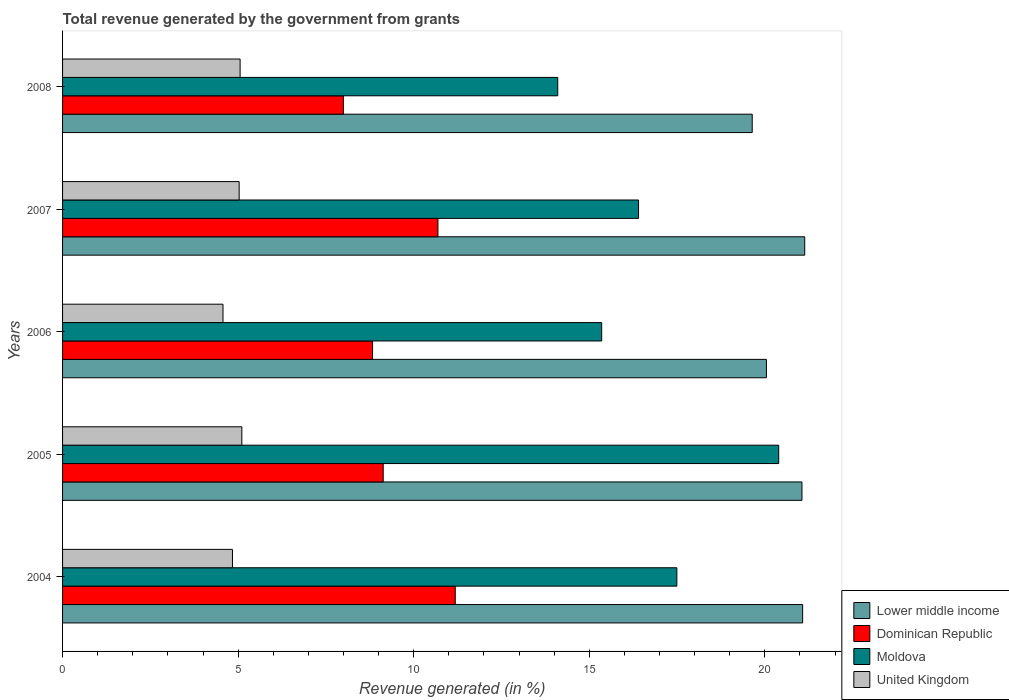How many different coloured bars are there?
Provide a short and direct response. 4. How many groups of bars are there?
Provide a short and direct response. 5. Are the number of bars per tick equal to the number of legend labels?
Make the answer very short. Yes. Are the number of bars on each tick of the Y-axis equal?
Offer a very short reply. Yes. What is the label of the 3rd group of bars from the top?
Your answer should be very brief. 2006. What is the total revenue generated in Lower middle income in 2007?
Keep it short and to the point. 21.14. Across all years, what is the maximum total revenue generated in Lower middle income?
Make the answer very short. 21.14. Across all years, what is the minimum total revenue generated in Dominican Republic?
Your answer should be compact. 8. In which year was the total revenue generated in Lower middle income maximum?
Your answer should be compact. 2007. What is the total total revenue generated in Lower middle income in the graph?
Provide a succinct answer. 102.96. What is the difference between the total revenue generated in United Kingdom in 2007 and that in 2008?
Ensure brevity in your answer.  -0.03. What is the difference between the total revenue generated in Dominican Republic in 2004 and the total revenue generated in United Kingdom in 2008?
Make the answer very short. 6.13. What is the average total revenue generated in United Kingdom per year?
Provide a short and direct response. 4.92. In the year 2008, what is the difference between the total revenue generated in Dominican Republic and total revenue generated in Moldova?
Give a very brief answer. -6.11. What is the ratio of the total revenue generated in Lower middle income in 2007 to that in 2008?
Ensure brevity in your answer.  1.08. Is the difference between the total revenue generated in Dominican Republic in 2004 and 2007 greater than the difference between the total revenue generated in Moldova in 2004 and 2007?
Provide a short and direct response. No. What is the difference between the highest and the second highest total revenue generated in Moldova?
Give a very brief answer. 2.9. What is the difference between the highest and the lowest total revenue generated in United Kingdom?
Your answer should be compact. 0.54. In how many years, is the total revenue generated in United Kingdom greater than the average total revenue generated in United Kingdom taken over all years?
Keep it short and to the point. 3. Is the sum of the total revenue generated in Dominican Republic in 2004 and 2005 greater than the maximum total revenue generated in Moldova across all years?
Give a very brief answer. No. Is it the case that in every year, the sum of the total revenue generated in Lower middle income and total revenue generated in Moldova is greater than the sum of total revenue generated in Dominican Republic and total revenue generated in United Kingdom?
Your answer should be compact. No. What does the 3rd bar from the top in 2007 represents?
Keep it short and to the point. Dominican Republic. What does the 4th bar from the bottom in 2004 represents?
Provide a succinct answer. United Kingdom. Is it the case that in every year, the sum of the total revenue generated in Lower middle income and total revenue generated in United Kingdom is greater than the total revenue generated in Moldova?
Your answer should be compact. Yes. Are all the bars in the graph horizontal?
Your answer should be compact. Yes. How many years are there in the graph?
Your response must be concise. 5. What is the difference between two consecutive major ticks on the X-axis?
Provide a short and direct response. 5. Does the graph contain grids?
Offer a terse response. No. What is the title of the graph?
Keep it short and to the point. Total revenue generated by the government from grants. Does "Nicaragua" appear as one of the legend labels in the graph?
Offer a very short reply. No. What is the label or title of the X-axis?
Keep it short and to the point. Revenue generated (in %). What is the Revenue generated (in %) of Lower middle income in 2004?
Keep it short and to the point. 21.08. What is the Revenue generated (in %) of Dominican Republic in 2004?
Your answer should be compact. 11.18. What is the Revenue generated (in %) in Moldova in 2004?
Ensure brevity in your answer.  17.5. What is the Revenue generated (in %) in United Kingdom in 2004?
Keep it short and to the point. 4.84. What is the Revenue generated (in %) of Lower middle income in 2005?
Offer a very short reply. 21.06. What is the Revenue generated (in %) in Dominican Republic in 2005?
Your answer should be compact. 9.13. What is the Revenue generated (in %) of Moldova in 2005?
Your answer should be compact. 20.4. What is the Revenue generated (in %) of United Kingdom in 2005?
Give a very brief answer. 5.11. What is the Revenue generated (in %) in Lower middle income in 2006?
Keep it short and to the point. 20.05. What is the Revenue generated (in %) in Dominican Republic in 2006?
Give a very brief answer. 8.83. What is the Revenue generated (in %) of Moldova in 2006?
Ensure brevity in your answer.  15.35. What is the Revenue generated (in %) in United Kingdom in 2006?
Ensure brevity in your answer.  4.57. What is the Revenue generated (in %) in Lower middle income in 2007?
Your answer should be compact. 21.14. What is the Revenue generated (in %) in Dominican Republic in 2007?
Offer a terse response. 10.69. What is the Revenue generated (in %) in Moldova in 2007?
Keep it short and to the point. 16.4. What is the Revenue generated (in %) in United Kingdom in 2007?
Keep it short and to the point. 5.03. What is the Revenue generated (in %) in Lower middle income in 2008?
Make the answer very short. 19.64. What is the Revenue generated (in %) in Dominican Republic in 2008?
Make the answer very short. 8. What is the Revenue generated (in %) of Moldova in 2008?
Keep it short and to the point. 14.1. What is the Revenue generated (in %) of United Kingdom in 2008?
Your answer should be compact. 5.06. Across all years, what is the maximum Revenue generated (in %) in Lower middle income?
Offer a terse response. 21.14. Across all years, what is the maximum Revenue generated (in %) of Dominican Republic?
Make the answer very short. 11.18. Across all years, what is the maximum Revenue generated (in %) of Moldova?
Offer a very short reply. 20.4. Across all years, what is the maximum Revenue generated (in %) in United Kingdom?
Provide a short and direct response. 5.11. Across all years, what is the minimum Revenue generated (in %) of Lower middle income?
Give a very brief answer. 19.64. Across all years, what is the minimum Revenue generated (in %) in Dominican Republic?
Give a very brief answer. 8. Across all years, what is the minimum Revenue generated (in %) in Moldova?
Make the answer very short. 14.1. Across all years, what is the minimum Revenue generated (in %) in United Kingdom?
Offer a very short reply. 4.57. What is the total Revenue generated (in %) of Lower middle income in the graph?
Ensure brevity in your answer.  102.96. What is the total Revenue generated (in %) of Dominican Republic in the graph?
Your response must be concise. 47.83. What is the total Revenue generated (in %) in Moldova in the graph?
Provide a short and direct response. 83.75. What is the total Revenue generated (in %) of United Kingdom in the graph?
Your response must be concise. 24.6. What is the difference between the Revenue generated (in %) in Lower middle income in 2004 and that in 2005?
Provide a short and direct response. 0.02. What is the difference between the Revenue generated (in %) in Dominican Republic in 2004 and that in 2005?
Provide a succinct answer. 2.05. What is the difference between the Revenue generated (in %) in Moldova in 2004 and that in 2005?
Provide a succinct answer. -2.9. What is the difference between the Revenue generated (in %) in United Kingdom in 2004 and that in 2005?
Your response must be concise. -0.27. What is the difference between the Revenue generated (in %) of Lower middle income in 2004 and that in 2006?
Provide a short and direct response. 1.03. What is the difference between the Revenue generated (in %) of Dominican Republic in 2004 and that in 2006?
Ensure brevity in your answer.  2.35. What is the difference between the Revenue generated (in %) in Moldova in 2004 and that in 2006?
Your answer should be very brief. 2.14. What is the difference between the Revenue generated (in %) of United Kingdom in 2004 and that in 2006?
Provide a short and direct response. 0.27. What is the difference between the Revenue generated (in %) in Lower middle income in 2004 and that in 2007?
Give a very brief answer. -0.06. What is the difference between the Revenue generated (in %) of Dominican Republic in 2004 and that in 2007?
Your answer should be compact. 0.49. What is the difference between the Revenue generated (in %) in Moldova in 2004 and that in 2007?
Keep it short and to the point. 1.09. What is the difference between the Revenue generated (in %) in United Kingdom in 2004 and that in 2007?
Give a very brief answer. -0.19. What is the difference between the Revenue generated (in %) of Lower middle income in 2004 and that in 2008?
Your response must be concise. 1.44. What is the difference between the Revenue generated (in %) in Dominican Republic in 2004 and that in 2008?
Offer a very short reply. 3.19. What is the difference between the Revenue generated (in %) of Moldova in 2004 and that in 2008?
Ensure brevity in your answer.  3.39. What is the difference between the Revenue generated (in %) in United Kingdom in 2004 and that in 2008?
Offer a terse response. -0.22. What is the difference between the Revenue generated (in %) in Lower middle income in 2005 and that in 2006?
Keep it short and to the point. 1.01. What is the difference between the Revenue generated (in %) of Dominican Republic in 2005 and that in 2006?
Provide a succinct answer. 0.3. What is the difference between the Revenue generated (in %) in Moldova in 2005 and that in 2006?
Offer a terse response. 5.04. What is the difference between the Revenue generated (in %) of United Kingdom in 2005 and that in 2006?
Provide a short and direct response. 0.54. What is the difference between the Revenue generated (in %) in Lower middle income in 2005 and that in 2007?
Your answer should be very brief. -0.08. What is the difference between the Revenue generated (in %) in Dominican Republic in 2005 and that in 2007?
Provide a short and direct response. -1.56. What is the difference between the Revenue generated (in %) of Moldova in 2005 and that in 2007?
Offer a terse response. 3.99. What is the difference between the Revenue generated (in %) in United Kingdom in 2005 and that in 2007?
Make the answer very short. 0.08. What is the difference between the Revenue generated (in %) of Lower middle income in 2005 and that in 2008?
Your answer should be very brief. 1.42. What is the difference between the Revenue generated (in %) of Dominican Republic in 2005 and that in 2008?
Your response must be concise. 1.14. What is the difference between the Revenue generated (in %) of Moldova in 2005 and that in 2008?
Make the answer very short. 6.29. What is the difference between the Revenue generated (in %) of United Kingdom in 2005 and that in 2008?
Make the answer very short. 0.05. What is the difference between the Revenue generated (in %) of Lower middle income in 2006 and that in 2007?
Offer a very short reply. -1.09. What is the difference between the Revenue generated (in %) of Dominican Republic in 2006 and that in 2007?
Keep it short and to the point. -1.86. What is the difference between the Revenue generated (in %) of Moldova in 2006 and that in 2007?
Make the answer very short. -1.05. What is the difference between the Revenue generated (in %) of United Kingdom in 2006 and that in 2007?
Keep it short and to the point. -0.46. What is the difference between the Revenue generated (in %) in Lower middle income in 2006 and that in 2008?
Ensure brevity in your answer.  0.4. What is the difference between the Revenue generated (in %) of Dominican Republic in 2006 and that in 2008?
Give a very brief answer. 0.83. What is the difference between the Revenue generated (in %) in Moldova in 2006 and that in 2008?
Provide a succinct answer. 1.25. What is the difference between the Revenue generated (in %) in United Kingdom in 2006 and that in 2008?
Offer a terse response. -0.49. What is the difference between the Revenue generated (in %) of Lower middle income in 2007 and that in 2008?
Provide a succinct answer. 1.5. What is the difference between the Revenue generated (in %) of Dominican Republic in 2007 and that in 2008?
Your response must be concise. 2.69. What is the difference between the Revenue generated (in %) in Moldova in 2007 and that in 2008?
Offer a terse response. 2.3. What is the difference between the Revenue generated (in %) in United Kingdom in 2007 and that in 2008?
Provide a succinct answer. -0.03. What is the difference between the Revenue generated (in %) in Lower middle income in 2004 and the Revenue generated (in %) in Dominican Republic in 2005?
Provide a succinct answer. 11.95. What is the difference between the Revenue generated (in %) in Lower middle income in 2004 and the Revenue generated (in %) in Moldova in 2005?
Give a very brief answer. 0.68. What is the difference between the Revenue generated (in %) in Lower middle income in 2004 and the Revenue generated (in %) in United Kingdom in 2005?
Make the answer very short. 15.97. What is the difference between the Revenue generated (in %) of Dominican Republic in 2004 and the Revenue generated (in %) of Moldova in 2005?
Your response must be concise. -9.21. What is the difference between the Revenue generated (in %) in Dominican Republic in 2004 and the Revenue generated (in %) in United Kingdom in 2005?
Provide a short and direct response. 6.08. What is the difference between the Revenue generated (in %) of Moldova in 2004 and the Revenue generated (in %) of United Kingdom in 2005?
Provide a succinct answer. 12.39. What is the difference between the Revenue generated (in %) in Lower middle income in 2004 and the Revenue generated (in %) in Dominican Republic in 2006?
Your answer should be very brief. 12.25. What is the difference between the Revenue generated (in %) of Lower middle income in 2004 and the Revenue generated (in %) of Moldova in 2006?
Give a very brief answer. 5.72. What is the difference between the Revenue generated (in %) of Lower middle income in 2004 and the Revenue generated (in %) of United Kingdom in 2006?
Give a very brief answer. 16.51. What is the difference between the Revenue generated (in %) of Dominican Republic in 2004 and the Revenue generated (in %) of Moldova in 2006?
Make the answer very short. -4.17. What is the difference between the Revenue generated (in %) of Dominican Republic in 2004 and the Revenue generated (in %) of United Kingdom in 2006?
Offer a very short reply. 6.61. What is the difference between the Revenue generated (in %) of Moldova in 2004 and the Revenue generated (in %) of United Kingdom in 2006?
Your response must be concise. 12.93. What is the difference between the Revenue generated (in %) in Lower middle income in 2004 and the Revenue generated (in %) in Dominican Republic in 2007?
Your answer should be compact. 10.39. What is the difference between the Revenue generated (in %) of Lower middle income in 2004 and the Revenue generated (in %) of Moldova in 2007?
Provide a short and direct response. 4.67. What is the difference between the Revenue generated (in %) in Lower middle income in 2004 and the Revenue generated (in %) in United Kingdom in 2007?
Your answer should be compact. 16.05. What is the difference between the Revenue generated (in %) of Dominican Republic in 2004 and the Revenue generated (in %) of Moldova in 2007?
Provide a succinct answer. -5.22. What is the difference between the Revenue generated (in %) of Dominican Republic in 2004 and the Revenue generated (in %) of United Kingdom in 2007?
Offer a terse response. 6.15. What is the difference between the Revenue generated (in %) of Moldova in 2004 and the Revenue generated (in %) of United Kingdom in 2007?
Your answer should be compact. 12.47. What is the difference between the Revenue generated (in %) of Lower middle income in 2004 and the Revenue generated (in %) of Dominican Republic in 2008?
Offer a terse response. 13.08. What is the difference between the Revenue generated (in %) in Lower middle income in 2004 and the Revenue generated (in %) in Moldova in 2008?
Your answer should be very brief. 6.97. What is the difference between the Revenue generated (in %) of Lower middle income in 2004 and the Revenue generated (in %) of United Kingdom in 2008?
Your answer should be compact. 16.02. What is the difference between the Revenue generated (in %) of Dominican Republic in 2004 and the Revenue generated (in %) of Moldova in 2008?
Your answer should be very brief. -2.92. What is the difference between the Revenue generated (in %) in Dominican Republic in 2004 and the Revenue generated (in %) in United Kingdom in 2008?
Your answer should be very brief. 6.13. What is the difference between the Revenue generated (in %) of Moldova in 2004 and the Revenue generated (in %) of United Kingdom in 2008?
Make the answer very short. 12.44. What is the difference between the Revenue generated (in %) in Lower middle income in 2005 and the Revenue generated (in %) in Dominican Republic in 2006?
Your answer should be compact. 12.23. What is the difference between the Revenue generated (in %) in Lower middle income in 2005 and the Revenue generated (in %) in Moldova in 2006?
Give a very brief answer. 5.7. What is the difference between the Revenue generated (in %) in Lower middle income in 2005 and the Revenue generated (in %) in United Kingdom in 2006?
Give a very brief answer. 16.49. What is the difference between the Revenue generated (in %) of Dominican Republic in 2005 and the Revenue generated (in %) of Moldova in 2006?
Provide a short and direct response. -6.22. What is the difference between the Revenue generated (in %) of Dominican Republic in 2005 and the Revenue generated (in %) of United Kingdom in 2006?
Your answer should be compact. 4.56. What is the difference between the Revenue generated (in %) in Moldova in 2005 and the Revenue generated (in %) in United Kingdom in 2006?
Provide a short and direct response. 15.83. What is the difference between the Revenue generated (in %) of Lower middle income in 2005 and the Revenue generated (in %) of Dominican Republic in 2007?
Your answer should be compact. 10.37. What is the difference between the Revenue generated (in %) in Lower middle income in 2005 and the Revenue generated (in %) in Moldova in 2007?
Provide a short and direct response. 4.65. What is the difference between the Revenue generated (in %) of Lower middle income in 2005 and the Revenue generated (in %) of United Kingdom in 2007?
Provide a short and direct response. 16.03. What is the difference between the Revenue generated (in %) in Dominican Republic in 2005 and the Revenue generated (in %) in Moldova in 2007?
Make the answer very short. -7.27. What is the difference between the Revenue generated (in %) of Dominican Republic in 2005 and the Revenue generated (in %) of United Kingdom in 2007?
Your answer should be compact. 4.1. What is the difference between the Revenue generated (in %) of Moldova in 2005 and the Revenue generated (in %) of United Kingdom in 2007?
Your answer should be very brief. 15.37. What is the difference between the Revenue generated (in %) of Lower middle income in 2005 and the Revenue generated (in %) of Dominican Republic in 2008?
Offer a very short reply. 13.06. What is the difference between the Revenue generated (in %) in Lower middle income in 2005 and the Revenue generated (in %) in Moldova in 2008?
Give a very brief answer. 6.96. What is the difference between the Revenue generated (in %) in Lower middle income in 2005 and the Revenue generated (in %) in United Kingdom in 2008?
Provide a succinct answer. 16. What is the difference between the Revenue generated (in %) in Dominican Republic in 2005 and the Revenue generated (in %) in Moldova in 2008?
Keep it short and to the point. -4.97. What is the difference between the Revenue generated (in %) in Dominican Republic in 2005 and the Revenue generated (in %) in United Kingdom in 2008?
Provide a succinct answer. 4.08. What is the difference between the Revenue generated (in %) in Moldova in 2005 and the Revenue generated (in %) in United Kingdom in 2008?
Your answer should be very brief. 15.34. What is the difference between the Revenue generated (in %) of Lower middle income in 2006 and the Revenue generated (in %) of Dominican Republic in 2007?
Your answer should be very brief. 9.36. What is the difference between the Revenue generated (in %) of Lower middle income in 2006 and the Revenue generated (in %) of Moldova in 2007?
Your answer should be compact. 3.64. What is the difference between the Revenue generated (in %) in Lower middle income in 2006 and the Revenue generated (in %) in United Kingdom in 2007?
Provide a short and direct response. 15.02. What is the difference between the Revenue generated (in %) in Dominican Republic in 2006 and the Revenue generated (in %) in Moldova in 2007?
Your answer should be compact. -7.58. What is the difference between the Revenue generated (in %) in Dominican Republic in 2006 and the Revenue generated (in %) in United Kingdom in 2007?
Your answer should be compact. 3.8. What is the difference between the Revenue generated (in %) in Moldova in 2006 and the Revenue generated (in %) in United Kingdom in 2007?
Provide a succinct answer. 10.33. What is the difference between the Revenue generated (in %) of Lower middle income in 2006 and the Revenue generated (in %) of Dominican Republic in 2008?
Offer a very short reply. 12.05. What is the difference between the Revenue generated (in %) of Lower middle income in 2006 and the Revenue generated (in %) of Moldova in 2008?
Your answer should be very brief. 5.94. What is the difference between the Revenue generated (in %) in Lower middle income in 2006 and the Revenue generated (in %) in United Kingdom in 2008?
Make the answer very short. 14.99. What is the difference between the Revenue generated (in %) in Dominican Republic in 2006 and the Revenue generated (in %) in Moldova in 2008?
Your answer should be compact. -5.27. What is the difference between the Revenue generated (in %) of Dominican Republic in 2006 and the Revenue generated (in %) of United Kingdom in 2008?
Provide a short and direct response. 3.77. What is the difference between the Revenue generated (in %) in Moldova in 2006 and the Revenue generated (in %) in United Kingdom in 2008?
Make the answer very short. 10.3. What is the difference between the Revenue generated (in %) of Lower middle income in 2007 and the Revenue generated (in %) of Dominican Republic in 2008?
Ensure brevity in your answer.  13.14. What is the difference between the Revenue generated (in %) of Lower middle income in 2007 and the Revenue generated (in %) of Moldova in 2008?
Ensure brevity in your answer.  7.03. What is the difference between the Revenue generated (in %) in Lower middle income in 2007 and the Revenue generated (in %) in United Kingdom in 2008?
Ensure brevity in your answer.  16.08. What is the difference between the Revenue generated (in %) of Dominican Republic in 2007 and the Revenue generated (in %) of Moldova in 2008?
Your answer should be compact. -3.41. What is the difference between the Revenue generated (in %) in Dominican Republic in 2007 and the Revenue generated (in %) in United Kingdom in 2008?
Offer a terse response. 5.63. What is the difference between the Revenue generated (in %) in Moldova in 2007 and the Revenue generated (in %) in United Kingdom in 2008?
Provide a short and direct response. 11.35. What is the average Revenue generated (in %) of Lower middle income per year?
Your response must be concise. 20.59. What is the average Revenue generated (in %) in Dominican Republic per year?
Your answer should be compact. 9.57. What is the average Revenue generated (in %) in Moldova per year?
Give a very brief answer. 16.75. What is the average Revenue generated (in %) of United Kingdom per year?
Offer a terse response. 4.92. In the year 2004, what is the difference between the Revenue generated (in %) of Lower middle income and Revenue generated (in %) of Dominican Republic?
Offer a terse response. 9.89. In the year 2004, what is the difference between the Revenue generated (in %) in Lower middle income and Revenue generated (in %) in Moldova?
Provide a succinct answer. 3.58. In the year 2004, what is the difference between the Revenue generated (in %) of Lower middle income and Revenue generated (in %) of United Kingdom?
Provide a succinct answer. 16.24. In the year 2004, what is the difference between the Revenue generated (in %) in Dominican Republic and Revenue generated (in %) in Moldova?
Your answer should be compact. -6.31. In the year 2004, what is the difference between the Revenue generated (in %) in Dominican Republic and Revenue generated (in %) in United Kingdom?
Ensure brevity in your answer.  6.35. In the year 2004, what is the difference between the Revenue generated (in %) in Moldova and Revenue generated (in %) in United Kingdom?
Offer a terse response. 12.66. In the year 2005, what is the difference between the Revenue generated (in %) of Lower middle income and Revenue generated (in %) of Dominican Republic?
Ensure brevity in your answer.  11.93. In the year 2005, what is the difference between the Revenue generated (in %) in Lower middle income and Revenue generated (in %) in Moldova?
Offer a terse response. 0.66. In the year 2005, what is the difference between the Revenue generated (in %) in Lower middle income and Revenue generated (in %) in United Kingdom?
Your answer should be very brief. 15.95. In the year 2005, what is the difference between the Revenue generated (in %) of Dominican Republic and Revenue generated (in %) of Moldova?
Your answer should be very brief. -11.26. In the year 2005, what is the difference between the Revenue generated (in %) in Dominican Republic and Revenue generated (in %) in United Kingdom?
Keep it short and to the point. 4.03. In the year 2005, what is the difference between the Revenue generated (in %) in Moldova and Revenue generated (in %) in United Kingdom?
Keep it short and to the point. 15.29. In the year 2006, what is the difference between the Revenue generated (in %) of Lower middle income and Revenue generated (in %) of Dominican Republic?
Make the answer very short. 11.22. In the year 2006, what is the difference between the Revenue generated (in %) of Lower middle income and Revenue generated (in %) of Moldova?
Ensure brevity in your answer.  4.69. In the year 2006, what is the difference between the Revenue generated (in %) in Lower middle income and Revenue generated (in %) in United Kingdom?
Offer a terse response. 15.48. In the year 2006, what is the difference between the Revenue generated (in %) of Dominican Republic and Revenue generated (in %) of Moldova?
Provide a succinct answer. -6.53. In the year 2006, what is the difference between the Revenue generated (in %) of Dominican Republic and Revenue generated (in %) of United Kingdom?
Keep it short and to the point. 4.26. In the year 2006, what is the difference between the Revenue generated (in %) of Moldova and Revenue generated (in %) of United Kingdom?
Provide a succinct answer. 10.79. In the year 2007, what is the difference between the Revenue generated (in %) of Lower middle income and Revenue generated (in %) of Dominican Republic?
Your answer should be very brief. 10.45. In the year 2007, what is the difference between the Revenue generated (in %) in Lower middle income and Revenue generated (in %) in Moldova?
Your answer should be compact. 4.73. In the year 2007, what is the difference between the Revenue generated (in %) of Lower middle income and Revenue generated (in %) of United Kingdom?
Offer a very short reply. 16.11. In the year 2007, what is the difference between the Revenue generated (in %) of Dominican Republic and Revenue generated (in %) of Moldova?
Keep it short and to the point. -5.71. In the year 2007, what is the difference between the Revenue generated (in %) of Dominican Republic and Revenue generated (in %) of United Kingdom?
Make the answer very short. 5.66. In the year 2007, what is the difference between the Revenue generated (in %) of Moldova and Revenue generated (in %) of United Kingdom?
Offer a very short reply. 11.37. In the year 2008, what is the difference between the Revenue generated (in %) in Lower middle income and Revenue generated (in %) in Dominican Republic?
Provide a short and direct response. 11.65. In the year 2008, what is the difference between the Revenue generated (in %) of Lower middle income and Revenue generated (in %) of Moldova?
Your answer should be very brief. 5.54. In the year 2008, what is the difference between the Revenue generated (in %) of Lower middle income and Revenue generated (in %) of United Kingdom?
Keep it short and to the point. 14.59. In the year 2008, what is the difference between the Revenue generated (in %) in Dominican Republic and Revenue generated (in %) in Moldova?
Provide a succinct answer. -6.11. In the year 2008, what is the difference between the Revenue generated (in %) in Dominican Republic and Revenue generated (in %) in United Kingdom?
Your answer should be very brief. 2.94. In the year 2008, what is the difference between the Revenue generated (in %) of Moldova and Revenue generated (in %) of United Kingdom?
Keep it short and to the point. 9.05. What is the ratio of the Revenue generated (in %) of Dominican Republic in 2004 to that in 2005?
Your response must be concise. 1.22. What is the ratio of the Revenue generated (in %) of Moldova in 2004 to that in 2005?
Your answer should be very brief. 0.86. What is the ratio of the Revenue generated (in %) in United Kingdom in 2004 to that in 2005?
Make the answer very short. 0.95. What is the ratio of the Revenue generated (in %) in Lower middle income in 2004 to that in 2006?
Provide a succinct answer. 1.05. What is the ratio of the Revenue generated (in %) of Dominican Republic in 2004 to that in 2006?
Offer a very short reply. 1.27. What is the ratio of the Revenue generated (in %) of Moldova in 2004 to that in 2006?
Keep it short and to the point. 1.14. What is the ratio of the Revenue generated (in %) of United Kingdom in 2004 to that in 2006?
Your answer should be compact. 1.06. What is the ratio of the Revenue generated (in %) in Dominican Republic in 2004 to that in 2007?
Your response must be concise. 1.05. What is the ratio of the Revenue generated (in %) in Moldova in 2004 to that in 2007?
Give a very brief answer. 1.07. What is the ratio of the Revenue generated (in %) of United Kingdom in 2004 to that in 2007?
Make the answer very short. 0.96. What is the ratio of the Revenue generated (in %) in Lower middle income in 2004 to that in 2008?
Your answer should be very brief. 1.07. What is the ratio of the Revenue generated (in %) of Dominican Republic in 2004 to that in 2008?
Offer a very short reply. 1.4. What is the ratio of the Revenue generated (in %) in Moldova in 2004 to that in 2008?
Provide a short and direct response. 1.24. What is the ratio of the Revenue generated (in %) of United Kingdom in 2004 to that in 2008?
Offer a terse response. 0.96. What is the ratio of the Revenue generated (in %) of Lower middle income in 2005 to that in 2006?
Keep it short and to the point. 1.05. What is the ratio of the Revenue generated (in %) of Dominican Republic in 2005 to that in 2006?
Ensure brevity in your answer.  1.03. What is the ratio of the Revenue generated (in %) in Moldova in 2005 to that in 2006?
Provide a succinct answer. 1.33. What is the ratio of the Revenue generated (in %) of United Kingdom in 2005 to that in 2006?
Your answer should be very brief. 1.12. What is the ratio of the Revenue generated (in %) in Dominican Republic in 2005 to that in 2007?
Ensure brevity in your answer.  0.85. What is the ratio of the Revenue generated (in %) of Moldova in 2005 to that in 2007?
Provide a succinct answer. 1.24. What is the ratio of the Revenue generated (in %) of United Kingdom in 2005 to that in 2007?
Your answer should be very brief. 1.02. What is the ratio of the Revenue generated (in %) in Lower middle income in 2005 to that in 2008?
Provide a succinct answer. 1.07. What is the ratio of the Revenue generated (in %) of Dominican Republic in 2005 to that in 2008?
Ensure brevity in your answer.  1.14. What is the ratio of the Revenue generated (in %) of Moldova in 2005 to that in 2008?
Provide a short and direct response. 1.45. What is the ratio of the Revenue generated (in %) in United Kingdom in 2005 to that in 2008?
Keep it short and to the point. 1.01. What is the ratio of the Revenue generated (in %) in Lower middle income in 2006 to that in 2007?
Provide a succinct answer. 0.95. What is the ratio of the Revenue generated (in %) in Dominican Republic in 2006 to that in 2007?
Your response must be concise. 0.83. What is the ratio of the Revenue generated (in %) in Moldova in 2006 to that in 2007?
Keep it short and to the point. 0.94. What is the ratio of the Revenue generated (in %) in United Kingdom in 2006 to that in 2007?
Make the answer very short. 0.91. What is the ratio of the Revenue generated (in %) in Lower middle income in 2006 to that in 2008?
Offer a very short reply. 1.02. What is the ratio of the Revenue generated (in %) in Dominican Republic in 2006 to that in 2008?
Your response must be concise. 1.1. What is the ratio of the Revenue generated (in %) in Moldova in 2006 to that in 2008?
Give a very brief answer. 1.09. What is the ratio of the Revenue generated (in %) of United Kingdom in 2006 to that in 2008?
Your response must be concise. 0.9. What is the ratio of the Revenue generated (in %) in Lower middle income in 2007 to that in 2008?
Ensure brevity in your answer.  1.08. What is the ratio of the Revenue generated (in %) of Dominican Republic in 2007 to that in 2008?
Your answer should be compact. 1.34. What is the ratio of the Revenue generated (in %) of Moldova in 2007 to that in 2008?
Offer a terse response. 1.16. What is the difference between the highest and the second highest Revenue generated (in %) in Lower middle income?
Give a very brief answer. 0.06. What is the difference between the highest and the second highest Revenue generated (in %) of Dominican Republic?
Your answer should be very brief. 0.49. What is the difference between the highest and the second highest Revenue generated (in %) in Moldova?
Your response must be concise. 2.9. What is the difference between the highest and the second highest Revenue generated (in %) of United Kingdom?
Give a very brief answer. 0.05. What is the difference between the highest and the lowest Revenue generated (in %) in Lower middle income?
Provide a short and direct response. 1.5. What is the difference between the highest and the lowest Revenue generated (in %) in Dominican Republic?
Offer a very short reply. 3.19. What is the difference between the highest and the lowest Revenue generated (in %) in Moldova?
Offer a terse response. 6.29. What is the difference between the highest and the lowest Revenue generated (in %) of United Kingdom?
Ensure brevity in your answer.  0.54. 